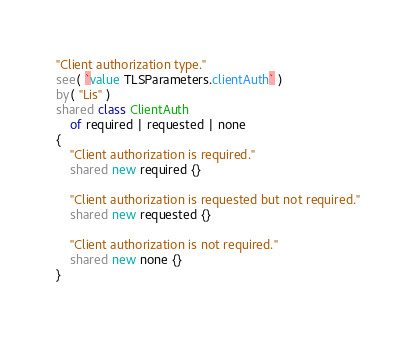<code> <loc_0><loc_0><loc_500><loc_500><_Ceylon_>

"Client authorization type."
see( `value TLSParameters.clientAuth` )
by( "Lis" )
shared class ClientAuth
	of required | requested | none
{
	"Client authorization is required."
	shared new required {}
	
	"Client authorization is requested but not required."
	shared new requested {}
	
	"Client authorization is not required."
	shared new none {}
}
</code> 